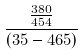Convert formula to latex. <formula><loc_0><loc_0><loc_500><loc_500>\frac { \frac { 3 8 0 } { 4 5 4 } } { ( 3 5 - 4 6 5 ) }</formula> 